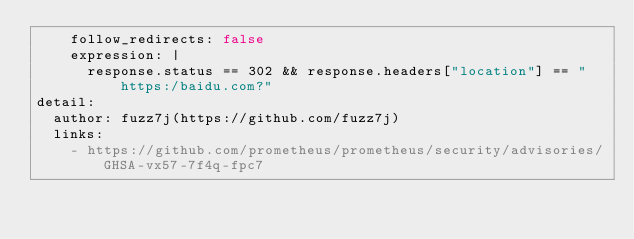<code> <loc_0><loc_0><loc_500><loc_500><_YAML_>    follow_redirects: false
    expression: |
      response.status == 302 && response.headers["location"] == "https:/baidu.com?"
detail:
  author: fuzz7j(https://github.com/fuzz7j)
  links:
    - https://github.com/prometheus/prometheus/security/advisories/GHSA-vx57-7f4q-fpc7
</code> 